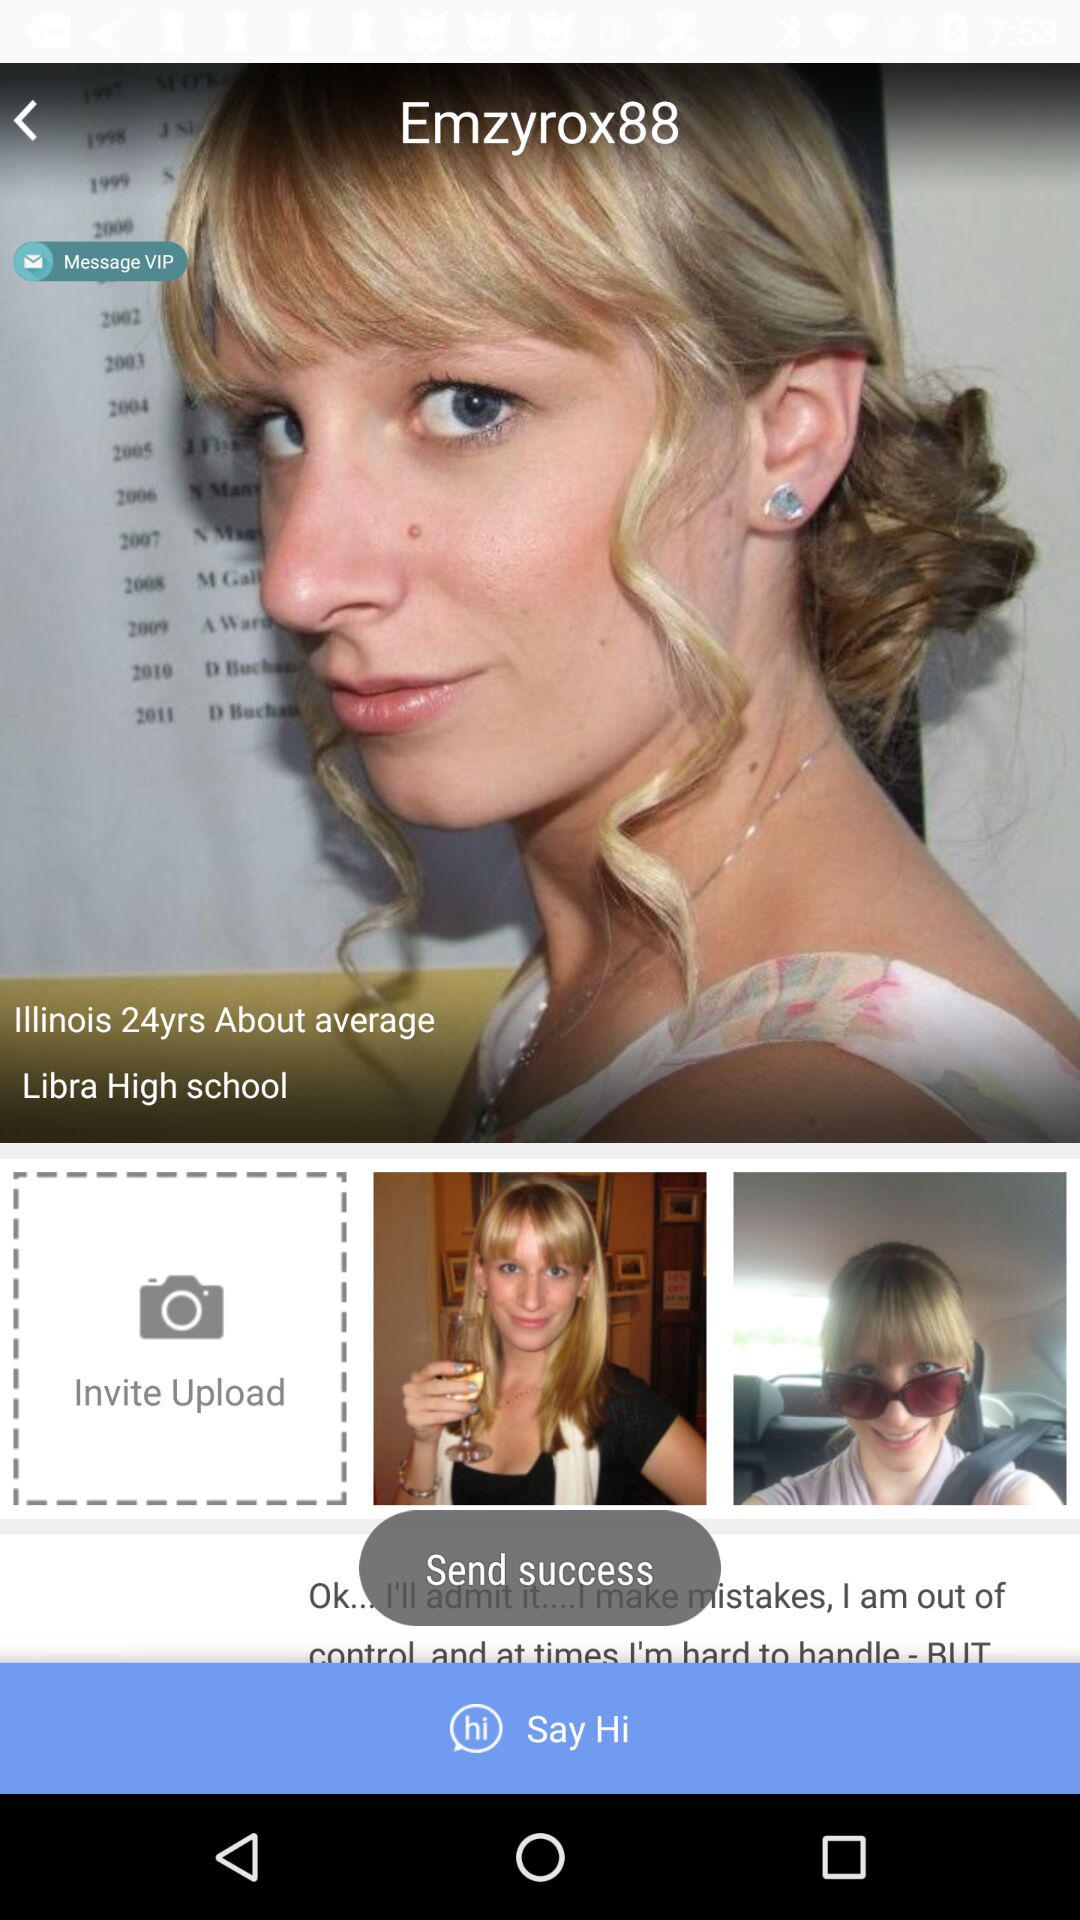What is the age of the user? The age of the user is 24 years old. 